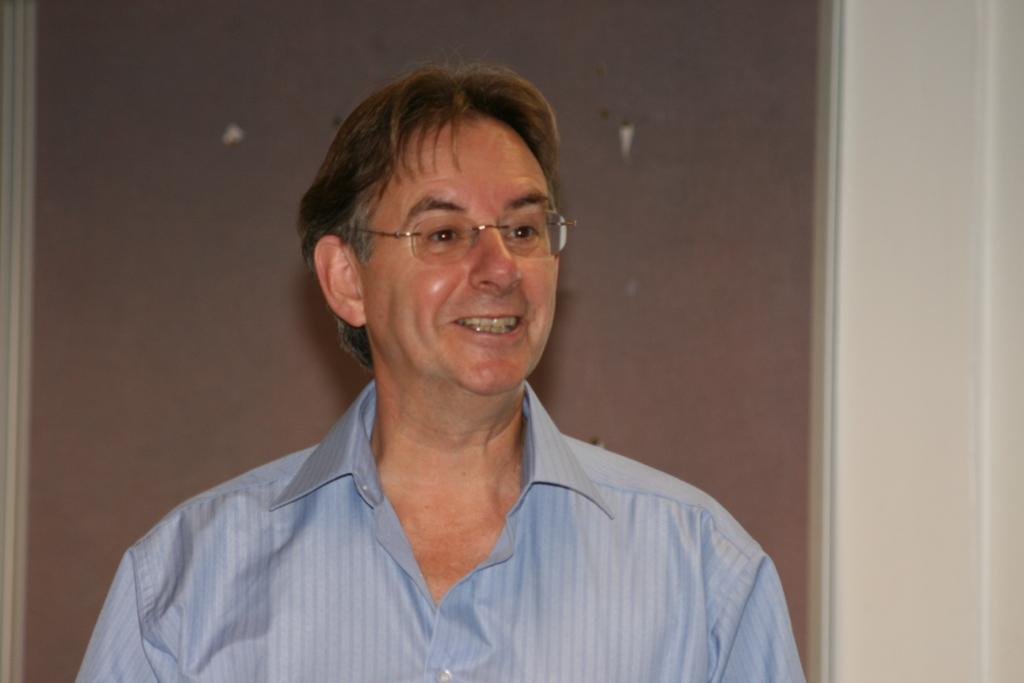What is the main subject of the image? There is a person in the image. What is the person wearing on their upper body? The person is wearing a blue shirt. Are there any accessories visible on the person? Yes, the person is wearing specs. What is the person's facial expression in the image? The person is smiling. Can you describe the background of the image? The background of the image is white and brown. How far away is the expert from the person in the image? There is no expert present in the image, so it is not possible to determine the distance between them. Is the person wearing a cap in the image? No, the person is not wearing a cap in the image; they are wearing a blue shirt and specs. 